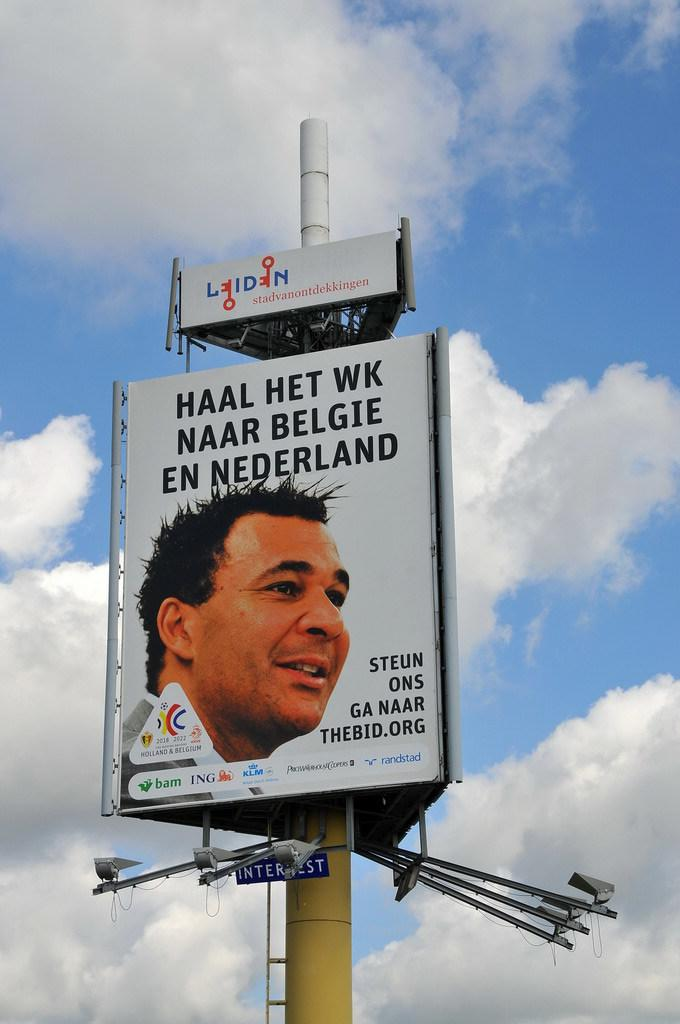<image>
Write a terse but informative summary of the picture. Large white sign that has a face and the words "STEUN ONS GA NAAR" on the bottom. 